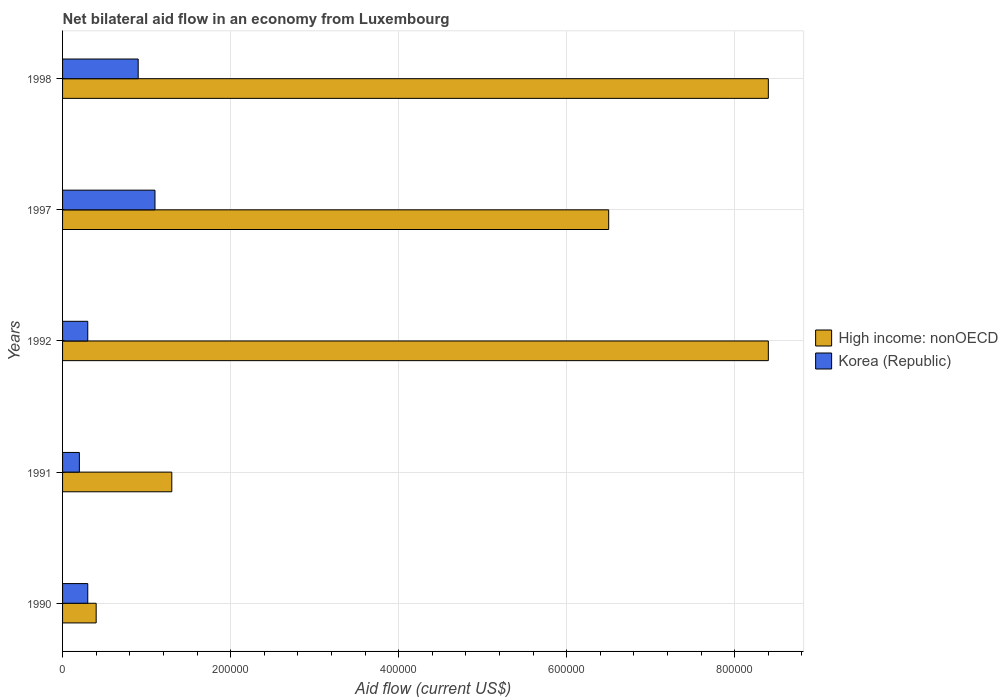How many different coloured bars are there?
Provide a short and direct response. 2. How many groups of bars are there?
Give a very brief answer. 5. Are the number of bars per tick equal to the number of legend labels?
Your response must be concise. Yes. How many bars are there on the 1st tick from the bottom?
Make the answer very short. 2. What is the label of the 4th group of bars from the top?
Your answer should be compact. 1991. In how many cases, is the number of bars for a given year not equal to the number of legend labels?
Your answer should be compact. 0. Across all years, what is the maximum net bilateral aid flow in Korea (Republic)?
Keep it short and to the point. 1.10e+05. Across all years, what is the minimum net bilateral aid flow in High income: nonOECD?
Your response must be concise. 4.00e+04. In which year was the net bilateral aid flow in High income: nonOECD minimum?
Offer a terse response. 1990. What is the difference between the net bilateral aid flow in Korea (Republic) in 1990 and that in 1991?
Offer a terse response. 10000. What is the difference between the net bilateral aid flow in Korea (Republic) in 1990 and the net bilateral aid flow in High income: nonOECD in 1992?
Your response must be concise. -8.10e+05. What is the average net bilateral aid flow in Korea (Republic) per year?
Offer a very short reply. 5.60e+04. In the year 1997, what is the difference between the net bilateral aid flow in High income: nonOECD and net bilateral aid flow in Korea (Republic)?
Provide a succinct answer. 5.40e+05. In how many years, is the net bilateral aid flow in High income: nonOECD greater than 760000 US$?
Give a very brief answer. 2. What is the difference between the highest and the lowest net bilateral aid flow in Korea (Republic)?
Offer a terse response. 9.00e+04. In how many years, is the net bilateral aid flow in Korea (Republic) greater than the average net bilateral aid flow in Korea (Republic) taken over all years?
Ensure brevity in your answer.  2. Is the sum of the net bilateral aid flow in Korea (Republic) in 1991 and 1997 greater than the maximum net bilateral aid flow in High income: nonOECD across all years?
Offer a terse response. No. What does the 2nd bar from the top in 1991 represents?
Your answer should be very brief. High income: nonOECD. What does the 2nd bar from the bottom in 1992 represents?
Provide a short and direct response. Korea (Republic). How many bars are there?
Give a very brief answer. 10. How many years are there in the graph?
Ensure brevity in your answer.  5. What is the difference between two consecutive major ticks on the X-axis?
Keep it short and to the point. 2.00e+05. Are the values on the major ticks of X-axis written in scientific E-notation?
Offer a very short reply. No. Does the graph contain any zero values?
Give a very brief answer. No. Does the graph contain grids?
Your response must be concise. Yes. Where does the legend appear in the graph?
Your response must be concise. Center right. How are the legend labels stacked?
Give a very brief answer. Vertical. What is the title of the graph?
Give a very brief answer. Net bilateral aid flow in an economy from Luxembourg. Does "Panama" appear as one of the legend labels in the graph?
Keep it short and to the point. No. What is the label or title of the X-axis?
Ensure brevity in your answer.  Aid flow (current US$). What is the label or title of the Y-axis?
Give a very brief answer. Years. What is the Aid flow (current US$) in High income: nonOECD in 1990?
Offer a very short reply. 4.00e+04. What is the Aid flow (current US$) in Korea (Republic) in 1990?
Give a very brief answer. 3.00e+04. What is the Aid flow (current US$) in Korea (Republic) in 1991?
Your answer should be compact. 2.00e+04. What is the Aid flow (current US$) in High income: nonOECD in 1992?
Give a very brief answer. 8.40e+05. What is the Aid flow (current US$) of Korea (Republic) in 1992?
Provide a succinct answer. 3.00e+04. What is the Aid flow (current US$) in High income: nonOECD in 1997?
Your answer should be very brief. 6.50e+05. What is the Aid flow (current US$) of High income: nonOECD in 1998?
Offer a very short reply. 8.40e+05. Across all years, what is the maximum Aid flow (current US$) in High income: nonOECD?
Offer a terse response. 8.40e+05. Across all years, what is the minimum Aid flow (current US$) of Korea (Republic)?
Make the answer very short. 2.00e+04. What is the total Aid flow (current US$) in High income: nonOECD in the graph?
Ensure brevity in your answer.  2.50e+06. What is the total Aid flow (current US$) of Korea (Republic) in the graph?
Keep it short and to the point. 2.80e+05. What is the difference between the Aid flow (current US$) of High income: nonOECD in 1990 and that in 1991?
Offer a very short reply. -9.00e+04. What is the difference between the Aid flow (current US$) in Korea (Republic) in 1990 and that in 1991?
Give a very brief answer. 10000. What is the difference between the Aid flow (current US$) of High income: nonOECD in 1990 and that in 1992?
Offer a terse response. -8.00e+05. What is the difference between the Aid flow (current US$) in Korea (Republic) in 1990 and that in 1992?
Offer a very short reply. 0. What is the difference between the Aid flow (current US$) in High income: nonOECD in 1990 and that in 1997?
Offer a very short reply. -6.10e+05. What is the difference between the Aid flow (current US$) in High income: nonOECD in 1990 and that in 1998?
Your response must be concise. -8.00e+05. What is the difference between the Aid flow (current US$) of High income: nonOECD in 1991 and that in 1992?
Your response must be concise. -7.10e+05. What is the difference between the Aid flow (current US$) in Korea (Republic) in 1991 and that in 1992?
Offer a terse response. -10000. What is the difference between the Aid flow (current US$) of High income: nonOECD in 1991 and that in 1997?
Make the answer very short. -5.20e+05. What is the difference between the Aid flow (current US$) in High income: nonOECD in 1991 and that in 1998?
Provide a succinct answer. -7.10e+05. What is the difference between the Aid flow (current US$) in Korea (Republic) in 1991 and that in 1998?
Your response must be concise. -7.00e+04. What is the difference between the Aid flow (current US$) in Korea (Republic) in 1992 and that in 1997?
Provide a short and direct response. -8.00e+04. What is the difference between the Aid flow (current US$) of High income: nonOECD in 1997 and that in 1998?
Your response must be concise. -1.90e+05. What is the difference between the Aid flow (current US$) of High income: nonOECD in 1990 and the Aid flow (current US$) of Korea (Republic) in 1991?
Ensure brevity in your answer.  2.00e+04. What is the difference between the Aid flow (current US$) of High income: nonOECD in 1990 and the Aid flow (current US$) of Korea (Republic) in 1992?
Offer a very short reply. 10000. What is the difference between the Aid flow (current US$) of High income: nonOECD in 1990 and the Aid flow (current US$) of Korea (Republic) in 1998?
Offer a very short reply. -5.00e+04. What is the difference between the Aid flow (current US$) in High income: nonOECD in 1991 and the Aid flow (current US$) in Korea (Republic) in 1997?
Ensure brevity in your answer.  2.00e+04. What is the difference between the Aid flow (current US$) of High income: nonOECD in 1991 and the Aid flow (current US$) of Korea (Republic) in 1998?
Give a very brief answer. 4.00e+04. What is the difference between the Aid flow (current US$) in High income: nonOECD in 1992 and the Aid flow (current US$) in Korea (Republic) in 1997?
Offer a terse response. 7.30e+05. What is the difference between the Aid flow (current US$) in High income: nonOECD in 1992 and the Aid flow (current US$) in Korea (Republic) in 1998?
Give a very brief answer. 7.50e+05. What is the difference between the Aid flow (current US$) of High income: nonOECD in 1997 and the Aid flow (current US$) of Korea (Republic) in 1998?
Offer a terse response. 5.60e+05. What is the average Aid flow (current US$) of Korea (Republic) per year?
Provide a succinct answer. 5.60e+04. In the year 1990, what is the difference between the Aid flow (current US$) in High income: nonOECD and Aid flow (current US$) in Korea (Republic)?
Give a very brief answer. 10000. In the year 1991, what is the difference between the Aid flow (current US$) of High income: nonOECD and Aid flow (current US$) of Korea (Republic)?
Provide a succinct answer. 1.10e+05. In the year 1992, what is the difference between the Aid flow (current US$) of High income: nonOECD and Aid flow (current US$) of Korea (Republic)?
Make the answer very short. 8.10e+05. In the year 1997, what is the difference between the Aid flow (current US$) in High income: nonOECD and Aid flow (current US$) in Korea (Republic)?
Give a very brief answer. 5.40e+05. In the year 1998, what is the difference between the Aid flow (current US$) in High income: nonOECD and Aid flow (current US$) in Korea (Republic)?
Keep it short and to the point. 7.50e+05. What is the ratio of the Aid flow (current US$) of High income: nonOECD in 1990 to that in 1991?
Keep it short and to the point. 0.31. What is the ratio of the Aid flow (current US$) in Korea (Republic) in 1990 to that in 1991?
Keep it short and to the point. 1.5. What is the ratio of the Aid flow (current US$) of High income: nonOECD in 1990 to that in 1992?
Provide a short and direct response. 0.05. What is the ratio of the Aid flow (current US$) in High income: nonOECD in 1990 to that in 1997?
Ensure brevity in your answer.  0.06. What is the ratio of the Aid flow (current US$) of Korea (Republic) in 1990 to that in 1997?
Your response must be concise. 0.27. What is the ratio of the Aid flow (current US$) of High income: nonOECD in 1990 to that in 1998?
Ensure brevity in your answer.  0.05. What is the ratio of the Aid flow (current US$) in Korea (Republic) in 1990 to that in 1998?
Offer a very short reply. 0.33. What is the ratio of the Aid flow (current US$) in High income: nonOECD in 1991 to that in 1992?
Provide a short and direct response. 0.15. What is the ratio of the Aid flow (current US$) in Korea (Republic) in 1991 to that in 1992?
Provide a short and direct response. 0.67. What is the ratio of the Aid flow (current US$) of Korea (Republic) in 1991 to that in 1997?
Keep it short and to the point. 0.18. What is the ratio of the Aid flow (current US$) of High income: nonOECD in 1991 to that in 1998?
Provide a short and direct response. 0.15. What is the ratio of the Aid flow (current US$) in Korea (Republic) in 1991 to that in 1998?
Your response must be concise. 0.22. What is the ratio of the Aid flow (current US$) in High income: nonOECD in 1992 to that in 1997?
Provide a short and direct response. 1.29. What is the ratio of the Aid flow (current US$) of Korea (Republic) in 1992 to that in 1997?
Keep it short and to the point. 0.27. What is the ratio of the Aid flow (current US$) in High income: nonOECD in 1997 to that in 1998?
Offer a very short reply. 0.77. What is the ratio of the Aid flow (current US$) in Korea (Republic) in 1997 to that in 1998?
Your answer should be very brief. 1.22. What is the difference between the highest and the second highest Aid flow (current US$) in High income: nonOECD?
Offer a very short reply. 0. What is the difference between the highest and the lowest Aid flow (current US$) in Korea (Republic)?
Provide a succinct answer. 9.00e+04. 